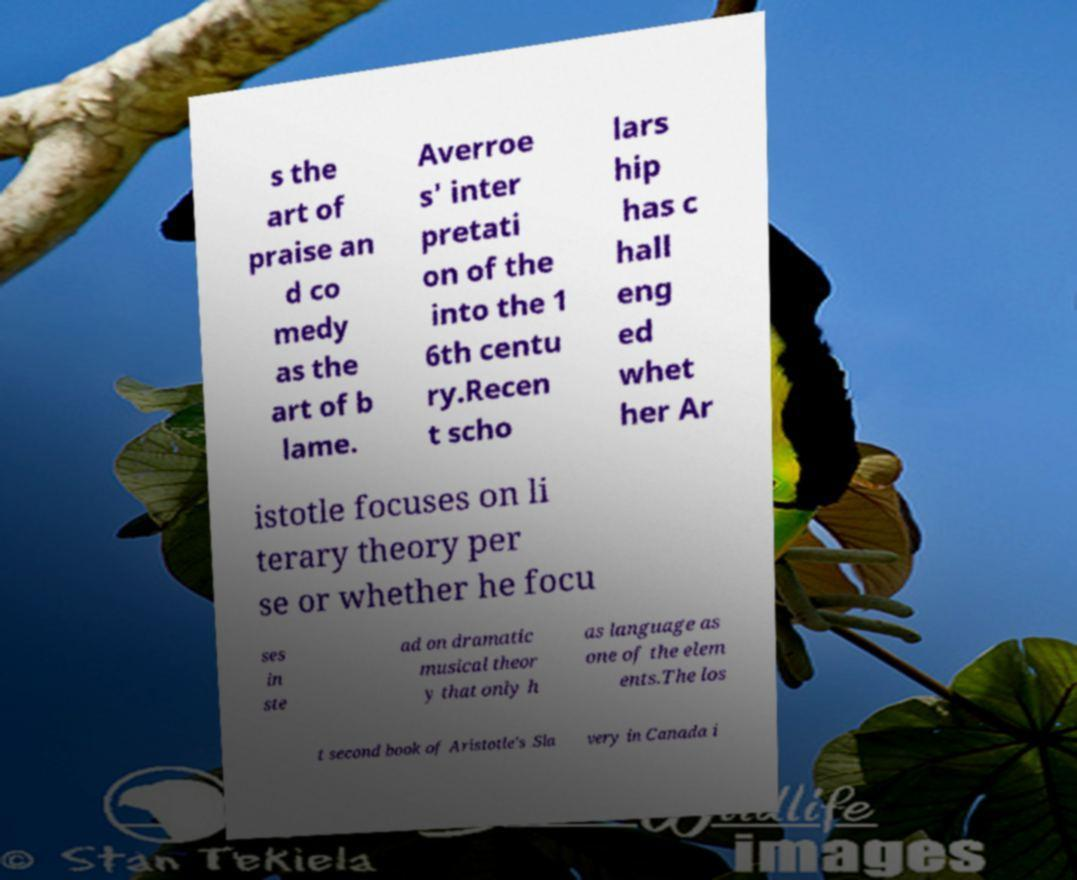Can you read and provide the text displayed in the image?This photo seems to have some interesting text. Can you extract and type it out for me? s the art of praise an d co medy as the art of b lame. Averroe s' inter pretati on of the into the 1 6th centu ry.Recen t scho lars hip has c hall eng ed whet her Ar istotle focuses on li terary theory per se or whether he focu ses in ste ad on dramatic musical theor y that only h as language as one of the elem ents.The los t second book of Aristotle's .Sla very in Canada i 